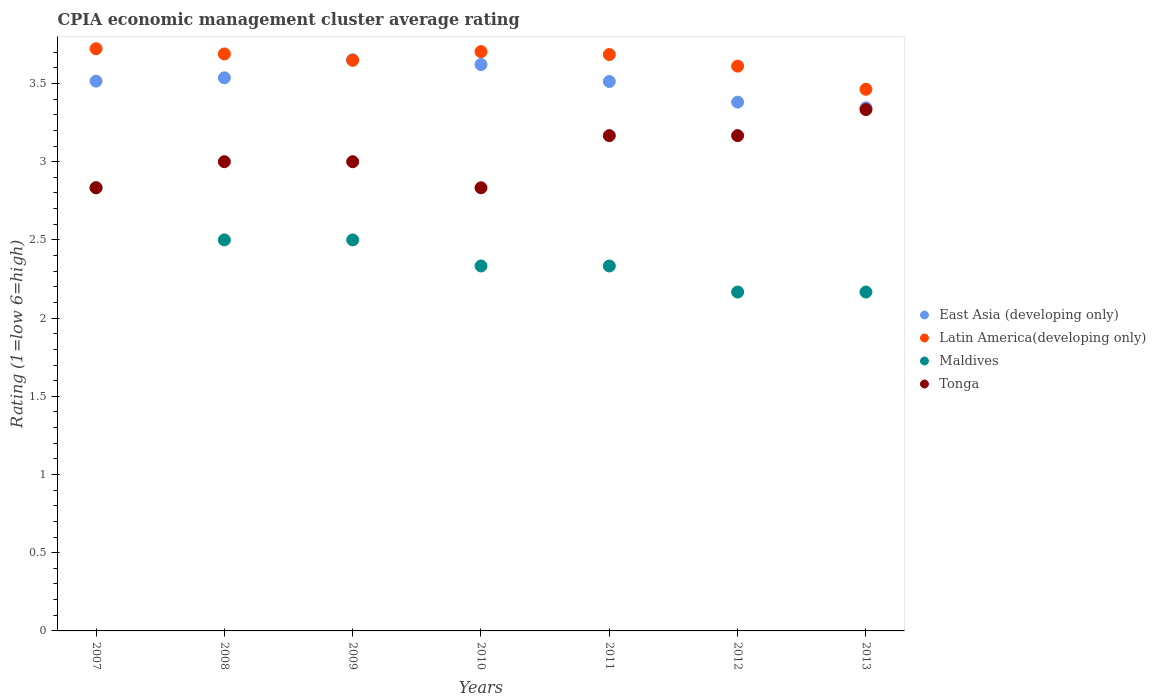How many different coloured dotlines are there?
Your answer should be very brief. 4. What is the CPIA rating in Maldives in 2007?
Your answer should be compact. 2.83. Across all years, what is the maximum CPIA rating in East Asia (developing only)?
Give a very brief answer. 3.65. Across all years, what is the minimum CPIA rating in Latin America(developing only)?
Offer a very short reply. 3.46. In which year was the CPIA rating in Maldives maximum?
Keep it short and to the point. 2007. What is the total CPIA rating in Tonga in the graph?
Make the answer very short. 21.33. What is the difference between the CPIA rating in Latin America(developing only) in 2011 and that in 2013?
Provide a succinct answer. 0.22. What is the difference between the CPIA rating in Tonga in 2013 and the CPIA rating in Latin America(developing only) in 2012?
Your response must be concise. -0.28. What is the average CPIA rating in Latin America(developing only) per year?
Offer a terse response. 3.65. In the year 2007, what is the difference between the CPIA rating in Maldives and CPIA rating in East Asia (developing only)?
Ensure brevity in your answer.  -0.68. In how many years, is the CPIA rating in Latin America(developing only) greater than 1.2?
Offer a very short reply. 7. Is the difference between the CPIA rating in Maldives in 2010 and 2011 greater than the difference between the CPIA rating in East Asia (developing only) in 2010 and 2011?
Keep it short and to the point. No. What is the difference between the highest and the second highest CPIA rating in Maldives?
Offer a very short reply. 0.33. What is the difference between the highest and the lowest CPIA rating in Maldives?
Provide a short and direct response. 0.67. Is the sum of the CPIA rating in Tonga in 2010 and 2012 greater than the maximum CPIA rating in East Asia (developing only) across all years?
Provide a short and direct response. Yes. Is the CPIA rating in East Asia (developing only) strictly greater than the CPIA rating in Latin America(developing only) over the years?
Make the answer very short. No. Is the CPIA rating in Maldives strictly less than the CPIA rating in Latin America(developing only) over the years?
Provide a short and direct response. Yes. How many dotlines are there?
Offer a very short reply. 4. What is the difference between two consecutive major ticks on the Y-axis?
Keep it short and to the point. 0.5. Are the values on the major ticks of Y-axis written in scientific E-notation?
Offer a terse response. No. Where does the legend appear in the graph?
Provide a succinct answer. Center right. What is the title of the graph?
Give a very brief answer. CPIA economic management cluster average rating. What is the label or title of the Y-axis?
Offer a very short reply. Rating (1=low 6=high). What is the Rating (1=low 6=high) of East Asia (developing only) in 2007?
Keep it short and to the point. 3.52. What is the Rating (1=low 6=high) of Latin America(developing only) in 2007?
Keep it short and to the point. 3.72. What is the Rating (1=low 6=high) in Maldives in 2007?
Your answer should be very brief. 2.83. What is the Rating (1=low 6=high) in Tonga in 2007?
Ensure brevity in your answer.  2.83. What is the Rating (1=low 6=high) of East Asia (developing only) in 2008?
Ensure brevity in your answer.  3.54. What is the Rating (1=low 6=high) in Latin America(developing only) in 2008?
Your answer should be very brief. 3.69. What is the Rating (1=low 6=high) of Maldives in 2008?
Your answer should be compact. 2.5. What is the Rating (1=low 6=high) of East Asia (developing only) in 2009?
Your answer should be very brief. 3.65. What is the Rating (1=low 6=high) in Latin America(developing only) in 2009?
Your answer should be very brief. 3.65. What is the Rating (1=low 6=high) of Tonga in 2009?
Make the answer very short. 3. What is the Rating (1=low 6=high) in East Asia (developing only) in 2010?
Your answer should be very brief. 3.62. What is the Rating (1=low 6=high) of Latin America(developing only) in 2010?
Provide a succinct answer. 3.7. What is the Rating (1=low 6=high) of Maldives in 2010?
Give a very brief answer. 2.33. What is the Rating (1=low 6=high) of Tonga in 2010?
Ensure brevity in your answer.  2.83. What is the Rating (1=low 6=high) in East Asia (developing only) in 2011?
Keep it short and to the point. 3.51. What is the Rating (1=low 6=high) in Latin America(developing only) in 2011?
Keep it short and to the point. 3.69. What is the Rating (1=low 6=high) in Maldives in 2011?
Keep it short and to the point. 2.33. What is the Rating (1=low 6=high) of Tonga in 2011?
Give a very brief answer. 3.17. What is the Rating (1=low 6=high) of East Asia (developing only) in 2012?
Your answer should be very brief. 3.38. What is the Rating (1=low 6=high) in Latin America(developing only) in 2012?
Make the answer very short. 3.61. What is the Rating (1=low 6=high) of Maldives in 2012?
Make the answer very short. 2.17. What is the Rating (1=low 6=high) in Tonga in 2012?
Your response must be concise. 3.17. What is the Rating (1=low 6=high) in East Asia (developing only) in 2013?
Your answer should be very brief. 3.34. What is the Rating (1=low 6=high) of Latin America(developing only) in 2013?
Your response must be concise. 3.46. What is the Rating (1=low 6=high) of Maldives in 2013?
Offer a terse response. 2.17. What is the Rating (1=low 6=high) of Tonga in 2013?
Provide a succinct answer. 3.33. Across all years, what is the maximum Rating (1=low 6=high) of East Asia (developing only)?
Provide a short and direct response. 3.65. Across all years, what is the maximum Rating (1=low 6=high) of Latin America(developing only)?
Provide a succinct answer. 3.72. Across all years, what is the maximum Rating (1=low 6=high) in Maldives?
Keep it short and to the point. 2.83. Across all years, what is the maximum Rating (1=low 6=high) in Tonga?
Offer a terse response. 3.33. Across all years, what is the minimum Rating (1=low 6=high) of East Asia (developing only)?
Offer a very short reply. 3.34. Across all years, what is the minimum Rating (1=low 6=high) in Latin America(developing only)?
Provide a succinct answer. 3.46. Across all years, what is the minimum Rating (1=low 6=high) in Maldives?
Your response must be concise. 2.17. Across all years, what is the minimum Rating (1=low 6=high) of Tonga?
Your answer should be compact. 2.83. What is the total Rating (1=low 6=high) in East Asia (developing only) in the graph?
Offer a terse response. 24.56. What is the total Rating (1=low 6=high) of Latin America(developing only) in the graph?
Your answer should be very brief. 25.52. What is the total Rating (1=low 6=high) in Maldives in the graph?
Ensure brevity in your answer.  16.83. What is the total Rating (1=low 6=high) in Tonga in the graph?
Ensure brevity in your answer.  21.33. What is the difference between the Rating (1=low 6=high) in East Asia (developing only) in 2007 and that in 2008?
Give a very brief answer. -0.02. What is the difference between the Rating (1=low 6=high) in Latin America(developing only) in 2007 and that in 2008?
Your answer should be very brief. 0.03. What is the difference between the Rating (1=low 6=high) of East Asia (developing only) in 2007 and that in 2009?
Give a very brief answer. -0.14. What is the difference between the Rating (1=low 6=high) of Latin America(developing only) in 2007 and that in 2009?
Provide a succinct answer. 0.07. What is the difference between the Rating (1=low 6=high) in Tonga in 2007 and that in 2009?
Keep it short and to the point. -0.17. What is the difference between the Rating (1=low 6=high) of East Asia (developing only) in 2007 and that in 2010?
Provide a succinct answer. -0.11. What is the difference between the Rating (1=low 6=high) of Latin America(developing only) in 2007 and that in 2010?
Your answer should be very brief. 0.02. What is the difference between the Rating (1=low 6=high) of Tonga in 2007 and that in 2010?
Offer a terse response. 0. What is the difference between the Rating (1=low 6=high) in East Asia (developing only) in 2007 and that in 2011?
Ensure brevity in your answer.  0. What is the difference between the Rating (1=low 6=high) of Latin America(developing only) in 2007 and that in 2011?
Ensure brevity in your answer.  0.04. What is the difference between the Rating (1=low 6=high) of East Asia (developing only) in 2007 and that in 2012?
Keep it short and to the point. 0.13. What is the difference between the Rating (1=low 6=high) in Latin America(developing only) in 2007 and that in 2012?
Your response must be concise. 0.11. What is the difference between the Rating (1=low 6=high) in East Asia (developing only) in 2007 and that in 2013?
Keep it short and to the point. 0.17. What is the difference between the Rating (1=low 6=high) of Latin America(developing only) in 2007 and that in 2013?
Offer a terse response. 0.26. What is the difference between the Rating (1=low 6=high) of Maldives in 2007 and that in 2013?
Your answer should be very brief. 0.67. What is the difference between the Rating (1=low 6=high) in East Asia (developing only) in 2008 and that in 2009?
Offer a very short reply. -0.12. What is the difference between the Rating (1=low 6=high) in Latin America(developing only) in 2008 and that in 2009?
Your answer should be very brief. 0.04. What is the difference between the Rating (1=low 6=high) in Tonga in 2008 and that in 2009?
Make the answer very short. 0. What is the difference between the Rating (1=low 6=high) of East Asia (developing only) in 2008 and that in 2010?
Give a very brief answer. -0.08. What is the difference between the Rating (1=low 6=high) in Latin America(developing only) in 2008 and that in 2010?
Offer a terse response. -0.01. What is the difference between the Rating (1=low 6=high) in Maldives in 2008 and that in 2010?
Offer a terse response. 0.17. What is the difference between the Rating (1=low 6=high) in East Asia (developing only) in 2008 and that in 2011?
Your answer should be compact. 0.02. What is the difference between the Rating (1=low 6=high) in Latin America(developing only) in 2008 and that in 2011?
Offer a terse response. 0. What is the difference between the Rating (1=low 6=high) in Maldives in 2008 and that in 2011?
Ensure brevity in your answer.  0.17. What is the difference between the Rating (1=low 6=high) in Tonga in 2008 and that in 2011?
Make the answer very short. -0.17. What is the difference between the Rating (1=low 6=high) in East Asia (developing only) in 2008 and that in 2012?
Offer a very short reply. 0.16. What is the difference between the Rating (1=low 6=high) in Latin America(developing only) in 2008 and that in 2012?
Offer a very short reply. 0.08. What is the difference between the Rating (1=low 6=high) in Tonga in 2008 and that in 2012?
Keep it short and to the point. -0.17. What is the difference between the Rating (1=low 6=high) of East Asia (developing only) in 2008 and that in 2013?
Provide a short and direct response. 0.19. What is the difference between the Rating (1=low 6=high) in Latin America(developing only) in 2008 and that in 2013?
Give a very brief answer. 0.23. What is the difference between the Rating (1=low 6=high) of Maldives in 2008 and that in 2013?
Offer a terse response. 0.33. What is the difference between the Rating (1=low 6=high) of East Asia (developing only) in 2009 and that in 2010?
Offer a very short reply. 0.03. What is the difference between the Rating (1=low 6=high) in Latin America(developing only) in 2009 and that in 2010?
Your answer should be very brief. -0.06. What is the difference between the Rating (1=low 6=high) of Maldives in 2009 and that in 2010?
Make the answer very short. 0.17. What is the difference between the Rating (1=low 6=high) of Tonga in 2009 and that in 2010?
Provide a short and direct response. 0.17. What is the difference between the Rating (1=low 6=high) in East Asia (developing only) in 2009 and that in 2011?
Keep it short and to the point. 0.14. What is the difference between the Rating (1=low 6=high) in Latin America(developing only) in 2009 and that in 2011?
Provide a succinct answer. -0.04. What is the difference between the Rating (1=low 6=high) of Tonga in 2009 and that in 2011?
Ensure brevity in your answer.  -0.17. What is the difference between the Rating (1=low 6=high) of East Asia (developing only) in 2009 and that in 2012?
Your response must be concise. 0.27. What is the difference between the Rating (1=low 6=high) in Latin America(developing only) in 2009 and that in 2012?
Make the answer very short. 0.04. What is the difference between the Rating (1=low 6=high) in East Asia (developing only) in 2009 and that in 2013?
Offer a very short reply. 0.31. What is the difference between the Rating (1=low 6=high) of Latin America(developing only) in 2009 and that in 2013?
Keep it short and to the point. 0.19. What is the difference between the Rating (1=low 6=high) of Maldives in 2009 and that in 2013?
Provide a succinct answer. 0.33. What is the difference between the Rating (1=low 6=high) of East Asia (developing only) in 2010 and that in 2011?
Your response must be concise. 0.11. What is the difference between the Rating (1=low 6=high) in Latin America(developing only) in 2010 and that in 2011?
Provide a succinct answer. 0.02. What is the difference between the Rating (1=low 6=high) in Maldives in 2010 and that in 2011?
Ensure brevity in your answer.  0. What is the difference between the Rating (1=low 6=high) of East Asia (developing only) in 2010 and that in 2012?
Give a very brief answer. 0.24. What is the difference between the Rating (1=low 6=high) in Latin America(developing only) in 2010 and that in 2012?
Offer a very short reply. 0.09. What is the difference between the Rating (1=low 6=high) in Tonga in 2010 and that in 2012?
Give a very brief answer. -0.33. What is the difference between the Rating (1=low 6=high) of East Asia (developing only) in 2010 and that in 2013?
Make the answer very short. 0.28. What is the difference between the Rating (1=low 6=high) in Latin America(developing only) in 2010 and that in 2013?
Your answer should be very brief. 0.24. What is the difference between the Rating (1=low 6=high) in Tonga in 2010 and that in 2013?
Give a very brief answer. -0.5. What is the difference between the Rating (1=low 6=high) in East Asia (developing only) in 2011 and that in 2012?
Offer a terse response. 0.13. What is the difference between the Rating (1=low 6=high) in Latin America(developing only) in 2011 and that in 2012?
Your response must be concise. 0.07. What is the difference between the Rating (1=low 6=high) of Maldives in 2011 and that in 2012?
Give a very brief answer. 0.17. What is the difference between the Rating (1=low 6=high) in East Asia (developing only) in 2011 and that in 2013?
Offer a terse response. 0.17. What is the difference between the Rating (1=low 6=high) of Latin America(developing only) in 2011 and that in 2013?
Offer a terse response. 0.22. What is the difference between the Rating (1=low 6=high) in Tonga in 2011 and that in 2013?
Your answer should be compact. -0.17. What is the difference between the Rating (1=low 6=high) of East Asia (developing only) in 2012 and that in 2013?
Your answer should be very brief. 0.04. What is the difference between the Rating (1=low 6=high) of Latin America(developing only) in 2012 and that in 2013?
Provide a succinct answer. 0.15. What is the difference between the Rating (1=low 6=high) of East Asia (developing only) in 2007 and the Rating (1=low 6=high) of Latin America(developing only) in 2008?
Keep it short and to the point. -0.17. What is the difference between the Rating (1=low 6=high) in East Asia (developing only) in 2007 and the Rating (1=low 6=high) in Maldives in 2008?
Offer a very short reply. 1.02. What is the difference between the Rating (1=low 6=high) of East Asia (developing only) in 2007 and the Rating (1=low 6=high) of Tonga in 2008?
Offer a terse response. 0.52. What is the difference between the Rating (1=low 6=high) in Latin America(developing only) in 2007 and the Rating (1=low 6=high) in Maldives in 2008?
Ensure brevity in your answer.  1.22. What is the difference between the Rating (1=low 6=high) in Latin America(developing only) in 2007 and the Rating (1=low 6=high) in Tonga in 2008?
Your response must be concise. 0.72. What is the difference between the Rating (1=low 6=high) of East Asia (developing only) in 2007 and the Rating (1=low 6=high) of Latin America(developing only) in 2009?
Your answer should be compact. -0.13. What is the difference between the Rating (1=low 6=high) in East Asia (developing only) in 2007 and the Rating (1=low 6=high) in Maldives in 2009?
Provide a succinct answer. 1.02. What is the difference between the Rating (1=low 6=high) in East Asia (developing only) in 2007 and the Rating (1=low 6=high) in Tonga in 2009?
Provide a succinct answer. 0.52. What is the difference between the Rating (1=low 6=high) of Latin America(developing only) in 2007 and the Rating (1=low 6=high) of Maldives in 2009?
Offer a terse response. 1.22. What is the difference between the Rating (1=low 6=high) of Latin America(developing only) in 2007 and the Rating (1=low 6=high) of Tonga in 2009?
Make the answer very short. 0.72. What is the difference between the Rating (1=low 6=high) in Maldives in 2007 and the Rating (1=low 6=high) in Tonga in 2009?
Ensure brevity in your answer.  -0.17. What is the difference between the Rating (1=low 6=high) in East Asia (developing only) in 2007 and the Rating (1=low 6=high) in Latin America(developing only) in 2010?
Ensure brevity in your answer.  -0.19. What is the difference between the Rating (1=low 6=high) of East Asia (developing only) in 2007 and the Rating (1=low 6=high) of Maldives in 2010?
Make the answer very short. 1.18. What is the difference between the Rating (1=low 6=high) in East Asia (developing only) in 2007 and the Rating (1=low 6=high) in Tonga in 2010?
Your answer should be compact. 0.68. What is the difference between the Rating (1=low 6=high) in Latin America(developing only) in 2007 and the Rating (1=low 6=high) in Maldives in 2010?
Your answer should be very brief. 1.39. What is the difference between the Rating (1=low 6=high) of Latin America(developing only) in 2007 and the Rating (1=low 6=high) of Tonga in 2010?
Keep it short and to the point. 0.89. What is the difference between the Rating (1=low 6=high) of Maldives in 2007 and the Rating (1=low 6=high) of Tonga in 2010?
Your answer should be very brief. 0. What is the difference between the Rating (1=low 6=high) in East Asia (developing only) in 2007 and the Rating (1=low 6=high) in Latin America(developing only) in 2011?
Provide a succinct answer. -0.17. What is the difference between the Rating (1=low 6=high) in East Asia (developing only) in 2007 and the Rating (1=low 6=high) in Maldives in 2011?
Keep it short and to the point. 1.18. What is the difference between the Rating (1=low 6=high) of East Asia (developing only) in 2007 and the Rating (1=low 6=high) of Tonga in 2011?
Give a very brief answer. 0.35. What is the difference between the Rating (1=low 6=high) in Latin America(developing only) in 2007 and the Rating (1=low 6=high) in Maldives in 2011?
Your response must be concise. 1.39. What is the difference between the Rating (1=low 6=high) of Latin America(developing only) in 2007 and the Rating (1=low 6=high) of Tonga in 2011?
Ensure brevity in your answer.  0.56. What is the difference between the Rating (1=low 6=high) of East Asia (developing only) in 2007 and the Rating (1=low 6=high) of Latin America(developing only) in 2012?
Your response must be concise. -0.1. What is the difference between the Rating (1=low 6=high) of East Asia (developing only) in 2007 and the Rating (1=low 6=high) of Maldives in 2012?
Provide a short and direct response. 1.35. What is the difference between the Rating (1=low 6=high) of East Asia (developing only) in 2007 and the Rating (1=low 6=high) of Tonga in 2012?
Offer a terse response. 0.35. What is the difference between the Rating (1=low 6=high) in Latin America(developing only) in 2007 and the Rating (1=low 6=high) in Maldives in 2012?
Your answer should be very brief. 1.56. What is the difference between the Rating (1=low 6=high) of Latin America(developing only) in 2007 and the Rating (1=low 6=high) of Tonga in 2012?
Provide a short and direct response. 0.56. What is the difference between the Rating (1=low 6=high) in Maldives in 2007 and the Rating (1=low 6=high) in Tonga in 2012?
Keep it short and to the point. -0.33. What is the difference between the Rating (1=low 6=high) in East Asia (developing only) in 2007 and the Rating (1=low 6=high) in Latin America(developing only) in 2013?
Provide a short and direct response. 0.05. What is the difference between the Rating (1=low 6=high) of East Asia (developing only) in 2007 and the Rating (1=low 6=high) of Maldives in 2013?
Your answer should be very brief. 1.35. What is the difference between the Rating (1=low 6=high) in East Asia (developing only) in 2007 and the Rating (1=low 6=high) in Tonga in 2013?
Your answer should be very brief. 0.18. What is the difference between the Rating (1=low 6=high) of Latin America(developing only) in 2007 and the Rating (1=low 6=high) of Maldives in 2013?
Your response must be concise. 1.56. What is the difference between the Rating (1=low 6=high) of Latin America(developing only) in 2007 and the Rating (1=low 6=high) of Tonga in 2013?
Offer a terse response. 0.39. What is the difference between the Rating (1=low 6=high) of Maldives in 2007 and the Rating (1=low 6=high) of Tonga in 2013?
Your answer should be very brief. -0.5. What is the difference between the Rating (1=low 6=high) of East Asia (developing only) in 2008 and the Rating (1=low 6=high) of Latin America(developing only) in 2009?
Ensure brevity in your answer.  -0.11. What is the difference between the Rating (1=low 6=high) of East Asia (developing only) in 2008 and the Rating (1=low 6=high) of Maldives in 2009?
Keep it short and to the point. 1.04. What is the difference between the Rating (1=low 6=high) in East Asia (developing only) in 2008 and the Rating (1=low 6=high) in Tonga in 2009?
Provide a succinct answer. 0.54. What is the difference between the Rating (1=low 6=high) of Latin America(developing only) in 2008 and the Rating (1=low 6=high) of Maldives in 2009?
Make the answer very short. 1.19. What is the difference between the Rating (1=low 6=high) in Latin America(developing only) in 2008 and the Rating (1=low 6=high) in Tonga in 2009?
Offer a very short reply. 0.69. What is the difference between the Rating (1=low 6=high) of East Asia (developing only) in 2008 and the Rating (1=low 6=high) of Latin America(developing only) in 2010?
Ensure brevity in your answer.  -0.17. What is the difference between the Rating (1=low 6=high) of East Asia (developing only) in 2008 and the Rating (1=low 6=high) of Maldives in 2010?
Ensure brevity in your answer.  1.2. What is the difference between the Rating (1=low 6=high) of East Asia (developing only) in 2008 and the Rating (1=low 6=high) of Tonga in 2010?
Your answer should be compact. 0.7. What is the difference between the Rating (1=low 6=high) in Latin America(developing only) in 2008 and the Rating (1=low 6=high) in Maldives in 2010?
Make the answer very short. 1.36. What is the difference between the Rating (1=low 6=high) of Latin America(developing only) in 2008 and the Rating (1=low 6=high) of Tonga in 2010?
Keep it short and to the point. 0.86. What is the difference between the Rating (1=low 6=high) in East Asia (developing only) in 2008 and the Rating (1=low 6=high) in Latin America(developing only) in 2011?
Your answer should be compact. -0.15. What is the difference between the Rating (1=low 6=high) in East Asia (developing only) in 2008 and the Rating (1=low 6=high) in Maldives in 2011?
Provide a succinct answer. 1.2. What is the difference between the Rating (1=low 6=high) of East Asia (developing only) in 2008 and the Rating (1=low 6=high) of Tonga in 2011?
Ensure brevity in your answer.  0.37. What is the difference between the Rating (1=low 6=high) in Latin America(developing only) in 2008 and the Rating (1=low 6=high) in Maldives in 2011?
Your response must be concise. 1.36. What is the difference between the Rating (1=low 6=high) in Latin America(developing only) in 2008 and the Rating (1=low 6=high) in Tonga in 2011?
Provide a succinct answer. 0.52. What is the difference between the Rating (1=low 6=high) of East Asia (developing only) in 2008 and the Rating (1=low 6=high) of Latin America(developing only) in 2012?
Provide a succinct answer. -0.07. What is the difference between the Rating (1=low 6=high) in East Asia (developing only) in 2008 and the Rating (1=low 6=high) in Maldives in 2012?
Offer a terse response. 1.37. What is the difference between the Rating (1=low 6=high) in East Asia (developing only) in 2008 and the Rating (1=low 6=high) in Tonga in 2012?
Ensure brevity in your answer.  0.37. What is the difference between the Rating (1=low 6=high) of Latin America(developing only) in 2008 and the Rating (1=low 6=high) of Maldives in 2012?
Offer a terse response. 1.52. What is the difference between the Rating (1=low 6=high) in Latin America(developing only) in 2008 and the Rating (1=low 6=high) in Tonga in 2012?
Offer a terse response. 0.52. What is the difference between the Rating (1=low 6=high) of East Asia (developing only) in 2008 and the Rating (1=low 6=high) of Latin America(developing only) in 2013?
Your answer should be compact. 0.07. What is the difference between the Rating (1=low 6=high) of East Asia (developing only) in 2008 and the Rating (1=low 6=high) of Maldives in 2013?
Keep it short and to the point. 1.37. What is the difference between the Rating (1=low 6=high) of East Asia (developing only) in 2008 and the Rating (1=low 6=high) of Tonga in 2013?
Make the answer very short. 0.2. What is the difference between the Rating (1=low 6=high) of Latin America(developing only) in 2008 and the Rating (1=low 6=high) of Maldives in 2013?
Your answer should be very brief. 1.52. What is the difference between the Rating (1=low 6=high) in Latin America(developing only) in 2008 and the Rating (1=low 6=high) in Tonga in 2013?
Make the answer very short. 0.36. What is the difference between the Rating (1=low 6=high) in Maldives in 2008 and the Rating (1=low 6=high) in Tonga in 2013?
Make the answer very short. -0.83. What is the difference between the Rating (1=low 6=high) in East Asia (developing only) in 2009 and the Rating (1=low 6=high) in Latin America(developing only) in 2010?
Ensure brevity in your answer.  -0.05. What is the difference between the Rating (1=low 6=high) in East Asia (developing only) in 2009 and the Rating (1=low 6=high) in Maldives in 2010?
Offer a terse response. 1.32. What is the difference between the Rating (1=low 6=high) in East Asia (developing only) in 2009 and the Rating (1=low 6=high) in Tonga in 2010?
Make the answer very short. 0.82. What is the difference between the Rating (1=low 6=high) of Latin America(developing only) in 2009 and the Rating (1=low 6=high) of Maldives in 2010?
Offer a terse response. 1.31. What is the difference between the Rating (1=low 6=high) in Latin America(developing only) in 2009 and the Rating (1=low 6=high) in Tonga in 2010?
Keep it short and to the point. 0.81. What is the difference between the Rating (1=low 6=high) in East Asia (developing only) in 2009 and the Rating (1=low 6=high) in Latin America(developing only) in 2011?
Provide a succinct answer. -0.03. What is the difference between the Rating (1=low 6=high) in East Asia (developing only) in 2009 and the Rating (1=low 6=high) in Maldives in 2011?
Your answer should be compact. 1.32. What is the difference between the Rating (1=low 6=high) of East Asia (developing only) in 2009 and the Rating (1=low 6=high) of Tonga in 2011?
Offer a terse response. 0.48. What is the difference between the Rating (1=low 6=high) in Latin America(developing only) in 2009 and the Rating (1=low 6=high) in Maldives in 2011?
Your response must be concise. 1.31. What is the difference between the Rating (1=low 6=high) in Latin America(developing only) in 2009 and the Rating (1=low 6=high) in Tonga in 2011?
Your answer should be compact. 0.48. What is the difference between the Rating (1=low 6=high) in East Asia (developing only) in 2009 and the Rating (1=low 6=high) in Latin America(developing only) in 2012?
Offer a very short reply. 0.04. What is the difference between the Rating (1=low 6=high) in East Asia (developing only) in 2009 and the Rating (1=low 6=high) in Maldives in 2012?
Your answer should be compact. 1.48. What is the difference between the Rating (1=low 6=high) of East Asia (developing only) in 2009 and the Rating (1=low 6=high) of Tonga in 2012?
Your answer should be compact. 0.48. What is the difference between the Rating (1=low 6=high) of Latin America(developing only) in 2009 and the Rating (1=low 6=high) of Maldives in 2012?
Provide a succinct answer. 1.48. What is the difference between the Rating (1=low 6=high) of Latin America(developing only) in 2009 and the Rating (1=low 6=high) of Tonga in 2012?
Provide a succinct answer. 0.48. What is the difference between the Rating (1=low 6=high) of Maldives in 2009 and the Rating (1=low 6=high) of Tonga in 2012?
Your answer should be very brief. -0.67. What is the difference between the Rating (1=low 6=high) in East Asia (developing only) in 2009 and the Rating (1=low 6=high) in Latin America(developing only) in 2013?
Give a very brief answer. 0.19. What is the difference between the Rating (1=low 6=high) of East Asia (developing only) in 2009 and the Rating (1=low 6=high) of Maldives in 2013?
Your response must be concise. 1.48. What is the difference between the Rating (1=low 6=high) of East Asia (developing only) in 2009 and the Rating (1=low 6=high) of Tonga in 2013?
Provide a succinct answer. 0.32. What is the difference between the Rating (1=low 6=high) in Latin America(developing only) in 2009 and the Rating (1=low 6=high) in Maldives in 2013?
Offer a terse response. 1.48. What is the difference between the Rating (1=low 6=high) in Latin America(developing only) in 2009 and the Rating (1=low 6=high) in Tonga in 2013?
Your answer should be compact. 0.31. What is the difference between the Rating (1=low 6=high) of East Asia (developing only) in 2010 and the Rating (1=low 6=high) of Latin America(developing only) in 2011?
Ensure brevity in your answer.  -0.06. What is the difference between the Rating (1=low 6=high) of East Asia (developing only) in 2010 and the Rating (1=low 6=high) of Maldives in 2011?
Your answer should be very brief. 1.29. What is the difference between the Rating (1=low 6=high) in East Asia (developing only) in 2010 and the Rating (1=low 6=high) in Tonga in 2011?
Your answer should be compact. 0.45. What is the difference between the Rating (1=low 6=high) in Latin America(developing only) in 2010 and the Rating (1=low 6=high) in Maldives in 2011?
Your response must be concise. 1.37. What is the difference between the Rating (1=low 6=high) in Latin America(developing only) in 2010 and the Rating (1=low 6=high) in Tonga in 2011?
Your answer should be very brief. 0.54. What is the difference between the Rating (1=low 6=high) in Maldives in 2010 and the Rating (1=low 6=high) in Tonga in 2011?
Offer a very short reply. -0.83. What is the difference between the Rating (1=low 6=high) of East Asia (developing only) in 2010 and the Rating (1=low 6=high) of Latin America(developing only) in 2012?
Your answer should be compact. 0.01. What is the difference between the Rating (1=low 6=high) of East Asia (developing only) in 2010 and the Rating (1=low 6=high) of Maldives in 2012?
Make the answer very short. 1.45. What is the difference between the Rating (1=low 6=high) of East Asia (developing only) in 2010 and the Rating (1=low 6=high) of Tonga in 2012?
Provide a succinct answer. 0.45. What is the difference between the Rating (1=low 6=high) in Latin America(developing only) in 2010 and the Rating (1=low 6=high) in Maldives in 2012?
Keep it short and to the point. 1.54. What is the difference between the Rating (1=low 6=high) in Latin America(developing only) in 2010 and the Rating (1=low 6=high) in Tonga in 2012?
Provide a succinct answer. 0.54. What is the difference between the Rating (1=low 6=high) in Maldives in 2010 and the Rating (1=low 6=high) in Tonga in 2012?
Your answer should be very brief. -0.83. What is the difference between the Rating (1=low 6=high) of East Asia (developing only) in 2010 and the Rating (1=low 6=high) of Latin America(developing only) in 2013?
Give a very brief answer. 0.16. What is the difference between the Rating (1=low 6=high) of East Asia (developing only) in 2010 and the Rating (1=low 6=high) of Maldives in 2013?
Give a very brief answer. 1.45. What is the difference between the Rating (1=low 6=high) of East Asia (developing only) in 2010 and the Rating (1=low 6=high) of Tonga in 2013?
Offer a very short reply. 0.29. What is the difference between the Rating (1=low 6=high) of Latin America(developing only) in 2010 and the Rating (1=low 6=high) of Maldives in 2013?
Your response must be concise. 1.54. What is the difference between the Rating (1=low 6=high) in Latin America(developing only) in 2010 and the Rating (1=low 6=high) in Tonga in 2013?
Your answer should be compact. 0.37. What is the difference between the Rating (1=low 6=high) in Maldives in 2010 and the Rating (1=low 6=high) in Tonga in 2013?
Provide a succinct answer. -1. What is the difference between the Rating (1=low 6=high) in East Asia (developing only) in 2011 and the Rating (1=low 6=high) in Latin America(developing only) in 2012?
Offer a very short reply. -0.1. What is the difference between the Rating (1=low 6=high) in East Asia (developing only) in 2011 and the Rating (1=low 6=high) in Maldives in 2012?
Give a very brief answer. 1.35. What is the difference between the Rating (1=low 6=high) of East Asia (developing only) in 2011 and the Rating (1=low 6=high) of Tonga in 2012?
Make the answer very short. 0.35. What is the difference between the Rating (1=low 6=high) in Latin America(developing only) in 2011 and the Rating (1=low 6=high) in Maldives in 2012?
Offer a terse response. 1.52. What is the difference between the Rating (1=low 6=high) of Latin America(developing only) in 2011 and the Rating (1=low 6=high) of Tonga in 2012?
Your answer should be very brief. 0.52. What is the difference between the Rating (1=low 6=high) of Maldives in 2011 and the Rating (1=low 6=high) of Tonga in 2012?
Offer a terse response. -0.83. What is the difference between the Rating (1=low 6=high) of East Asia (developing only) in 2011 and the Rating (1=low 6=high) of Latin America(developing only) in 2013?
Your answer should be compact. 0.05. What is the difference between the Rating (1=low 6=high) of East Asia (developing only) in 2011 and the Rating (1=low 6=high) of Maldives in 2013?
Make the answer very short. 1.35. What is the difference between the Rating (1=low 6=high) in East Asia (developing only) in 2011 and the Rating (1=low 6=high) in Tonga in 2013?
Provide a succinct answer. 0.18. What is the difference between the Rating (1=low 6=high) in Latin America(developing only) in 2011 and the Rating (1=low 6=high) in Maldives in 2013?
Your answer should be very brief. 1.52. What is the difference between the Rating (1=low 6=high) of Latin America(developing only) in 2011 and the Rating (1=low 6=high) of Tonga in 2013?
Offer a very short reply. 0.35. What is the difference between the Rating (1=low 6=high) of Maldives in 2011 and the Rating (1=low 6=high) of Tonga in 2013?
Ensure brevity in your answer.  -1. What is the difference between the Rating (1=low 6=high) in East Asia (developing only) in 2012 and the Rating (1=low 6=high) in Latin America(developing only) in 2013?
Ensure brevity in your answer.  -0.08. What is the difference between the Rating (1=low 6=high) in East Asia (developing only) in 2012 and the Rating (1=low 6=high) in Maldives in 2013?
Your answer should be compact. 1.21. What is the difference between the Rating (1=low 6=high) in East Asia (developing only) in 2012 and the Rating (1=low 6=high) in Tonga in 2013?
Your answer should be compact. 0.05. What is the difference between the Rating (1=low 6=high) in Latin America(developing only) in 2012 and the Rating (1=low 6=high) in Maldives in 2013?
Make the answer very short. 1.44. What is the difference between the Rating (1=low 6=high) in Latin America(developing only) in 2012 and the Rating (1=low 6=high) in Tonga in 2013?
Make the answer very short. 0.28. What is the difference between the Rating (1=low 6=high) of Maldives in 2012 and the Rating (1=low 6=high) of Tonga in 2013?
Provide a short and direct response. -1.17. What is the average Rating (1=low 6=high) of East Asia (developing only) per year?
Ensure brevity in your answer.  3.51. What is the average Rating (1=low 6=high) in Latin America(developing only) per year?
Your response must be concise. 3.65. What is the average Rating (1=low 6=high) of Maldives per year?
Give a very brief answer. 2.4. What is the average Rating (1=low 6=high) in Tonga per year?
Keep it short and to the point. 3.05. In the year 2007, what is the difference between the Rating (1=low 6=high) in East Asia (developing only) and Rating (1=low 6=high) in Latin America(developing only)?
Ensure brevity in your answer.  -0.21. In the year 2007, what is the difference between the Rating (1=low 6=high) of East Asia (developing only) and Rating (1=low 6=high) of Maldives?
Keep it short and to the point. 0.68. In the year 2007, what is the difference between the Rating (1=low 6=high) in East Asia (developing only) and Rating (1=low 6=high) in Tonga?
Provide a succinct answer. 0.68. In the year 2008, what is the difference between the Rating (1=low 6=high) of East Asia (developing only) and Rating (1=low 6=high) of Latin America(developing only)?
Offer a very short reply. -0.15. In the year 2008, what is the difference between the Rating (1=low 6=high) of East Asia (developing only) and Rating (1=low 6=high) of Maldives?
Offer a terse response. 1.04. In the year 2008, what is the difference between the Rating (1=low 6=high) in East Asia (developing only) and Rating (1=low 6=high) in Tonga?
Offer a terse response. 0.54. In the year 2008, what is the difference between the Rating (1=low 6=high) of Latin America(developing only) and Rating (1=low 6=high) of Maldives?
Ensure brevity in your answer.  1.19. In the year 2008, what is the difference between the Rating (1=low 6=high) of Latin America(developing only) and Rating (1=low 6=high) of Tonga?
Give a very brief answer. 0.69. In the year 2008, what is the difference between the Rating (1=low 6=high) in Maldives and Rating (1=low 6=high) in Tonga?
Keep it short and to the point. -0.5. In the year 2009, what is the difference between the Rating (1=low 6=high) of East Asia (developing only) and Rating (1=low 6=high) of Latin America(developing only)?
Offer a very short reply. 0. In the year 2009, what is the difference between the Rating (1=low 6=high) of East Asia (developing only) and Rating (1=low 6=high) of Maldives?
Your answer should be compact. 1.15. In the year 2009, what is the difference between the Rating (1=low 6=high) in East Asia (developing only) and Rating (1=low 6=high) in Tonga?
Keep it short and to the point. 0.65. In the year 2009, what is the difference between the Rating (1=low 6=high) of Latin America(developing only) and Rating (1=low 6=high) of Maldives?
Provide a short and direct response. 1.15. In the year 2009, what is the difference between the Rating (1=low 6=high) of Latin America(developing only) and Rating (1=low 6=high) of Tonga?
Give a very brief answer. 0.65. In the year 2009, what is the difference between the Rating (1=low 6=high) in Maldives and Rating (1=low 6=high) in Tonga?
Provide a succinct answer. -0.5. In the year 2010, what is the difference between the Rating (1=low 6=high) in East Asia (developing only) and Rating (1=low 6=high) in Latin America(developing only)?
Offer a terse response. -0.08. In the year 2010, what is the difference between the Rating (1=low 6=high) in East Asia (developing only) and Rating (1=low 6=high) in Maldives?
Ensure brevity in your answer.  1.29. In the year 2010, what is the difference between the Rating (1=low 6=high) in East Asia (developing only) and Rating (1=low 6=high) in Tonga?
Provide a short and direct response. 0.79. In the year 2010, what is the difference between the Rating (1=low 6=high) of Latin America(developing only) and Rating (1=low 6=high) of Maldives?
Offer a very short reply. 1.37. In the year 2010, what is the difference between the Rating (1=low 6=high) of Latin America(developing only) and Rating (1=low 6=high) of Tonga?
Offer a very short reply. 0.87. In the year 2010, what is the difference between the Rating (1=low 6=high) in Maldives and Rating (1=low 6=high) in Tonga?
Your answer should be very brief. -0.5. In the year 2011, what is the difference between the Rating (1=low 6=high) in East Asia (developing only) and Rating (1=low 6=high) in Latin America(developing only)?
Your response must be concise. -0.17. In the year 2011, what is the difference between the Rating (1=low 6=high) of East Asia (developing only) and Rating (1=low 6=high) of Maldives?
Provide a short and direct response. 1.18. In the year 2011, what is the difference between the Rating (1=low 6=high) in East Asia (developing only) and Rating (1=low 6=high) in Tonga?
Offer a terse response. 0.35. In the year 2011, what is the difference between the Rating (1=low 6=high) of Latin America(developing only) and Rating (1=low 6=high) of Maldives?
Provide a succinct answer. 1.35. In the year 2011, what is the difference between the Rating (1=low 6=high) of Latin America(developing only) and Rating (1=low 6=high) of Tonga?
Your answer should be very brief. 0.52. In the year 2012, what is the difference between the Rating (1=low 6=high) in East Asia (developing only) and Rating (1=low 6=high) in Latin America(developing only)?
Your response must be concise. -0.23. In the year 2012, what is the difference between the Rating (1=low 6=high) of East Asia (developing only) and Rating (1=low 6=high) of Maldives?
Provide a succinct answer. 1.21. In the year 2012, what is the difference between the Rating (1=low 6=high) in East Asia (developing only) and Rating (1=low 6=high) in Tonga?
Give a very brief answer. 0.21. In the year 2012, what is the difference between the Rating (1=low 6=high) in Latin America(developing only) and Rating (1=low 6=high) in Maldives?
Keep it short and to the point. 1.44. In the year 2012, what is the difference between the Rating (1=low 6=high) of Latin America(developing only) and Rating (1=low 6=high) of Tonga?
Provide a short and direct response. 0.44. In the year 2013, what is the difference between the Rating (1=low 6=high) in East Asia (developing only) and Rating (1=low 6=high) in Latin America(developing only)?
Your response must be concise. -0.12. In the year 2013, what is the difference between the Rating (1=low 6=high) in East Asia (developing only) and Rating (1=low 6=high) in Maldives?
Give a very brief answer. 1.18. In the year 2013, what is the difference between the Rating (1=low 6=high) of East Asia (developing only) and Rating (1=low 6=high) of Tonga?
Make the answer very short. 0.01. In the year 2013, what is the difference between the Rating (1=low 6=high) in Latin America(developing only) and Rating (1=low 6=high) in Maldives?
Offer a very short reply. 1.3. In the year 2013, what is the difference between the Rating (1=low 6=high) in Latin America(developing only) and Rating (1=low 6=high) in Tonga?
Offer a very short reply. 0.13. In the year 2013, what is the difference between the Rating (1=low 6=high) in Maldives and Rating (1=low 6=high) in Tonga?
Keep it short and to the point. -1.17. What is the ratio of the Rating (1=low 6=high) in Latin America(developing only) in 2007 to that in 2008?
Make the answer very short. 1.01. What is the ratio of the Rating (1=low 6=high) of Maldives in 2007 to that in 2008?
Ensure brevity in your answer.  1.13. What is the ratio of the Rating (1=low 6=high) of East Asia (developing only) in 2007 to that in 2009?
Keep it short and to the point. 0.96. What is the ratio of the Rating (1=low 6=high) of Latin America(developing only) in 2007 to that in 2009?
Your answer should be compact. 1.02. What is the ratio of the Rating (1=low 6=high) in Maldives in 2007 to that in 2009?
Ensure brevity in your answer.  1.13. What is the ratio of the Rating (1=low 6=high) in East Asia (developing only) in 2007 to that in 2010?
Ensure brevity in your answer.  0.97. What is the ratio of the Rating (1=low 6=high) of Latin America(developing only) in 2007 to that in 2010?
Ensure brevity in your answer.  1. What is the ratio of the Rating (1=low 6=high) of Maldives in 2007 to that in 2010?
Provide a succinct answer. 1.21. What is the ratio of the Rating (1=low 6=high) in East Asia (developing only) in 2007 to that in 2011?
Ensure brevity in your answer.  1. What is the ratio of the Rating (1=low 6=high) in Maldives in 2007 to that in 2011?
Provide a short and direct response. 1.21. What is the ratio of the Rating (1=low 6=high) of Tonga in 2007 to that in 2011?
Provide a succinct answer. 0.89. What is the ratio of the Rating (1=low 6=high) in East Asia (developing only) in 2007 to that in 2012?
Give a very brief answer. 1.04. What is the ratio of the Rating (1=low 6=high) in Latin America(developing only) in 2007 to that in 2012?
Your answer should be very brief. 1.03. What is the ratio of the Rating (1=low 6=high) of Maldives in 2007 to that in 2012?
Give a very brief answer. 1.31. What is the ratio of the Rating (1=low 6=high) of Tonga in 2007 to that in 2012?
Offer a terse response. 0.89. What is the ratio of the Rating (1=low 6=high) in East Asia (developing only) in 2007 to that in 2013?
Ensure brevity in your answer.  1.05. What is the ratio of the Rating (1=low 6=high) of Latin America(developing only) in 2007 to that in 2013?
Keep it short and to the point. 1.07. What is the ratio of the Rating (1=low 6=high) in Maldives in 2007 to that in 2013?
Make the answer very short. 1.31. What is the ratio of the Rating (1=low 6=high) of Tonga in 2007 to that in 2013?
Your answer should be compact. 0.85. What is the ratio of the Rating (1=low 6=high) in East Asia (developing only) in 2008 to that in 2009?
Give a very brief answer. 0.97. What is the ratio of the Rating (1=low 6=high) in Latin America(developing only) in 2008 to that in 2009?
Give a very brief answer. 1.01. What is the ratio of the Rating (1=low 6=high) of Tonga in 2008 to that in 2009?
Ensure brevity in your answer.  1. What is the ratio of the Rating (1=low 6=high) in East Asia (developing only) in 2008 to that in 2010?
Your answer should be very brief. 0.98. What is the ratio of the Rating (1=low 6=high) in Latin America(developing only) in 2008 to that in 2010?
Provide a succinct answer. 1. What is the ratio of the Rating (1=low 6=high) of Maldives in 2008 to that in 2010?
Your answer should be compact. 1.07. What is the ratio of the Rating (1=low 6=high) of Tonga in 2008 to that in 2010?
Your answer should be very brief. 1.06. What is the ratio of the Rating (1=low 6=high) in Latin America(developing only) in 2008 to that in 2011?
Your answer should be compact. 1. What is the ratio of the Rating (1=low 6=high) in Maldives in 2008 to that in 2011?
Offer a terse response. 1.07. What is the ratio of the Rating (1=low 6=high) of East Asia (developing only) in 2008 to that in 2012?
Make the answer very short. 1.05. What is the ratio of the Rating (1=low 6=high) in Latin America(developing only) in 2008 to that in 2012?
Keep it short and to the point. 1.02. What is the ratio of the Rating (1=low 6=high) in Maldives in 2008 to that in 2012?
Offer a very short reply. 1.15. What is the ratio of the Rating (1=low 6=high) in Tonga in 2008 to that in 2012?
Your answer should be very brief. 0.95. What is the ratio of the Rating (1=low 6=high) of East Asia (developing only) in 2008 to that in 2013?
Your response must be concise. 1.06. What is the ratio of the Rating (1=low 6=high) in Latin America(developing only) in 2008 to that in 2013?
Your answer should be compact. 1.07. What is the ratio of the Rating (1=low 6=high) in Maldives in 2008 to that in 2013?
Make the answer very short. 1.15. What is the ratio of the Rating (1=low 6=high) of Tonga in 2008 to that in 2013?
Provide a short and direct response. 0.9. What is the ratio of the Rating (1=low 6=high) of East Asia (developing only) in 2009 to that in 2010?
Make the answer very short. 1.01. What is the ratio of the Rating (1=low 6=high) in Maldives in 2009 to that in 2010?
Give a very brief answer. 1.07. What is the ratio of the Rating (1=low 6=high) in Tonga in 2009 to that in 2010?
Your response must be concise. 1.06. What is the ratio of the Rating (1=low 6=high) of East Asia (developing only) in 2009 to that in 2011?
Provide a short and direct response. 1.04. What is the ratio of the Rating (1=low 6=high) in Latin America(developing only) in 2009 to that in 2011?
Keep it short and to the point. 0.99. What is the ratio of the Rating (1=low 6=high) of Maldives in 2009 to that in 2011?
Make the answer very short. 1.07. What is the ratio of the Rating (1=low 6=high) of East Asia (developing only) in 2009 to that in 2012?
Provide a short and direct response. 1.08. What is the ratio of the Rating (1=low 6=high) in Latin America(developing only) in 2009 to that in 2012?
Offer a very short reply. 1.01. What is the ratio of the Rating (1=low 6=high) in Maldives in 2009 to that in 2012?
Keep it short and to the point. 1.15. What is the ratio of the Rating (1=low 6=high) of Tonga in 2009 to that in 2012?
Keep it short and to the point. 0.95. What is the ratio of the Rating (1=low 6=high) in East Asia (developing only) in 2009 to that in 2013?
Keep it short and to the point. 1.09. What is the ratio of the Rating (1=low 6=high) of Latin America(developing only) in 2009 to that in 2013?
Provide a short and direct response. 1.05. What is the ratio of the Rating (1=low 6=high) in Maldives in 2009 to that in 2013?
Offer a very short reply. 1.15. What is the ratio of the Rating (1=low 6=high) of East Asia (developing only) in 2010 to that in 2011?
Offer a very short reply. 1.03. What is the ratio of the Rating (1=low 6=high) of Latin America(developing only) in 2010 to that in 2011?
Offer a terse response. 1. What is the ratio of the Rating (1=low 6=high) in Maldives in 2010 to that in 2011?
Your answer should be very brief. 1. What is the ratio of the Rating (1=low 6=high) of Tonga in 2010 to that in 2011?
Provide a succinct answer. 0.89. What is the ratio of the Rating (1=low 6=high) in East Asia (developing only) in 2010 to that in 2012?
Make the answer very short. 1.07. What is the ratio of the Rating (1=low 6=high) of Latin America(developing only) in 2010 to that in 2012?
Offer a very short reply. 1.03. What is the ratio of the Rating (1=low 6=high) in Maldives in 2010 to that in 2012?
Your response must be concise. 1.08. What is the ratio of the Rating (1=low 6=high) in Tonga in 2010 to that in 2012?
Offer a very short reply. 0.89. What is the ratio of the Rating (1=low 6=high) in East Asia (developing only) in 2010 to that in 2013?
Your answer should be compact. 1.08. What is the ratio of the Rating (1=low 6=high) of Latin America(developing only) in 2010 to that in 2013?
Ensure brevity in your answer.  1.07. What is the ratio of the Rating (1=low 6=high) in Maldives in 2010 to that in 2013?
Your answer should be compact. 1.08. What is the ratio of the Rating (1=low 6=high) of East Asia (developing only) in 2011 to that in 2012?
Provide a short and direct response. 1.04. What is the ratio of the Rating (1=low 6=high) in Latin America(developing only) in 2011 to that in 2012?
Ensure brevity in your answer.  1.02. What is the ratio of the Rating (1=low 6=high) in Tonga in 2011 to that in 2012?
Provide a short and direct response. 1. What is the ratio of the Rating (1=low 6=high) in East Asia (developing only) in 2011 to that in 2013?
Give a very brief answer. 1.05. What is the ratio of the Rating (1=low 6=high) in Latin America(developing only) in 2011 to that in 2013?
Your response must be concise. 1.06. What is the ratio of the Rating (1=low 6=high) in Tonga in 2011 to that in 2013?
Provide a short and direct response. 0.95. What is the ratio of the Rating (1=low 6=high) of East Asia (developing only) in 2012 to that in 2013?
Offer a terse response. 1.01. What is the ratio of the Rating (1=low 6=high) of Latin America(developing only) in 2012 to that in 2013?
Offer a terse response. 1.04. What is the difference between the highest and the second highest Rating (1=low 6=high) of East Asia (developing only)?
Give a very brief answer. 0.03. What is the difference between the highest and the second highest Rating (1=low 6=high) of Latin America(developing only)?
Keep it short and to the point. 0.02. What is the difference between the highest and the second highest Rating (1=low 6=high) of Maldives?
Offer a very short reply. 0.33. What is the difference between the highest and the lowest Rating (1=low 6=high) of East Asia (developing only)?
Your answer should be compact. 0.31. What is the difference between the highest and the lowest Rating (1=low 6=high) in Latin America(developing only)?
Ensure brevity in your answer.  0.26. What is the difference between the highest and the lowest Rating (1=low 6=high) of Tonga?
Offer a very short reply. 0.5. 